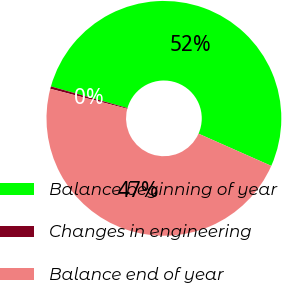Convert chart to OTSL. <chart><loc_0><loc_0><loc_500><loc_500><pie_chart><fcel>Balance beginning of year<fcel>Changes in engineering<fcel>Balance end of year<nl><fcel>52.24%<fcel>0.34%<fcel>47.41%<nl></chart> 